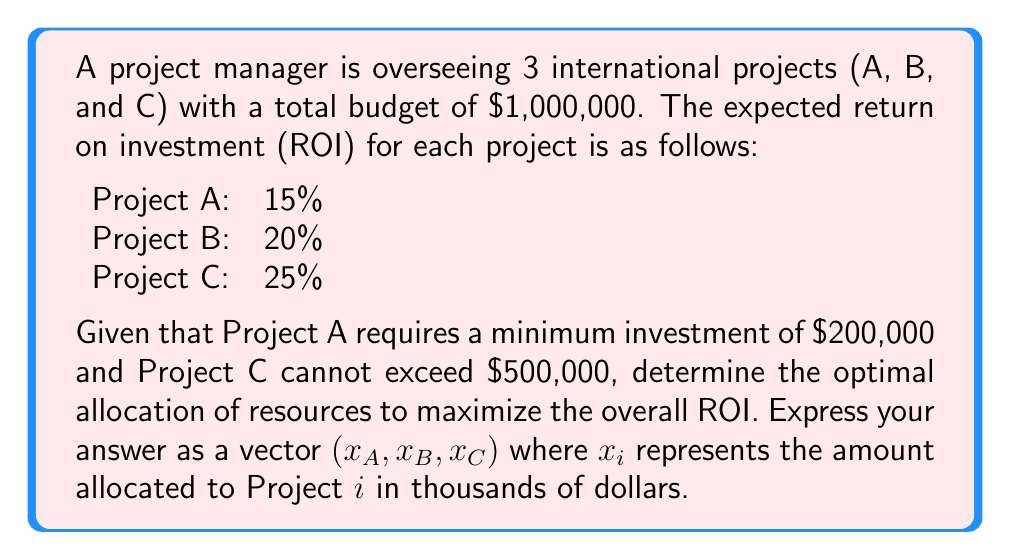Provide a solution to this math problem. Let's approach this step-by-step using linear programming:

1) Define variables:
   $x_A$, $x_B$, $x_C$ : amount allocated to Projects A, B, and C respectively (in thousands of dollars)

2) Objective function (to maximize):
   $$f(x_A, x_B, x_C) = 0.15x_A + 0.20x_B + 0.25x_C$$

3) Constraints:
   $$x_A + x_B + x_C = 1000$$ (total budget)
   $$x_A \geq 200$$ (minimum for Project A)
   $$x_C \leq 500$$ (maximum for Project C)
   $$x_A, x_B, x_C \geq 0$$ (non-negativity)

4) To maximize ROI, we should allocate as much as possible to the project with the highest ROI (Project C), then to the next highest (Project B), and finally to Project A.

5) Optimal allocation:
   - Allocate maximum to C: $x_C = 500$
   - Allocate minimum to A: $x_A = 200$
   - Remaining goes to B: $x_B = 1000 - 500 - 200 = 300$

6) Check constraints:
   - Total: 200 + 300 + 500 = 1000 (satisfied)
   - A ≥ 200 (satisfied)
   - C ≤ 500 (satisfied)
   - All non-negative (satisfied)

7) Calculate ROI:
   $$0.15(200) + 0.20(300) + 0.25(500) = 30 + 60 + 125 = 215$$

   The maximum ROI is 21.5%
Answer: $(200, 300, 500)$ 